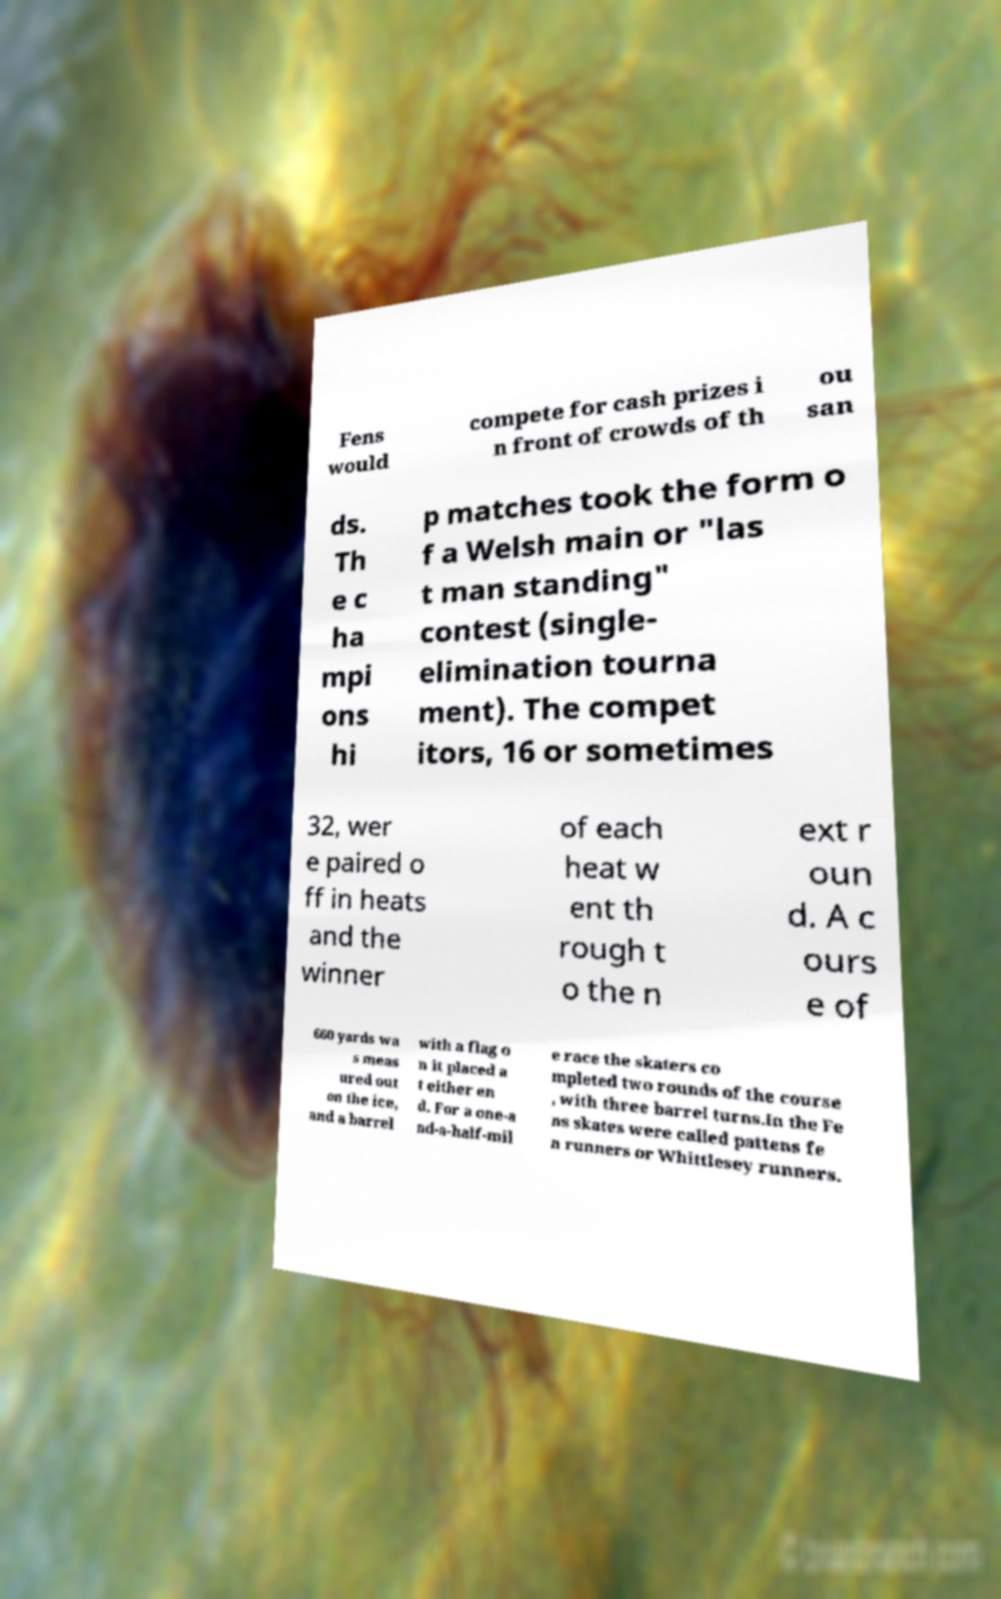What messages or text are displayed in this image? I need them in a readable, typed format. Fens would compete for cash prizes i n front of crowds of th ou san ds. Th e c ha mpi ons hi p matches took the form o f a Welsh main or "las t man standing" contest (single- elimination tourna ment). The compet itors, 16 or sometimes 32, wer e paired o ff in heats and the winner of each heat w ent th rough t o the n ext r oun d. A c ours e of 660 yards wa s meas ured out on the ice, and a barrel with a flag o n it placed a t either en d. For a one-a nd-a-half-mil e race the skaters co mpleted two rounds of the course , with three barrel turns.In the Fe ns skates were called pattens fe n runners or Whittlesey runners. 